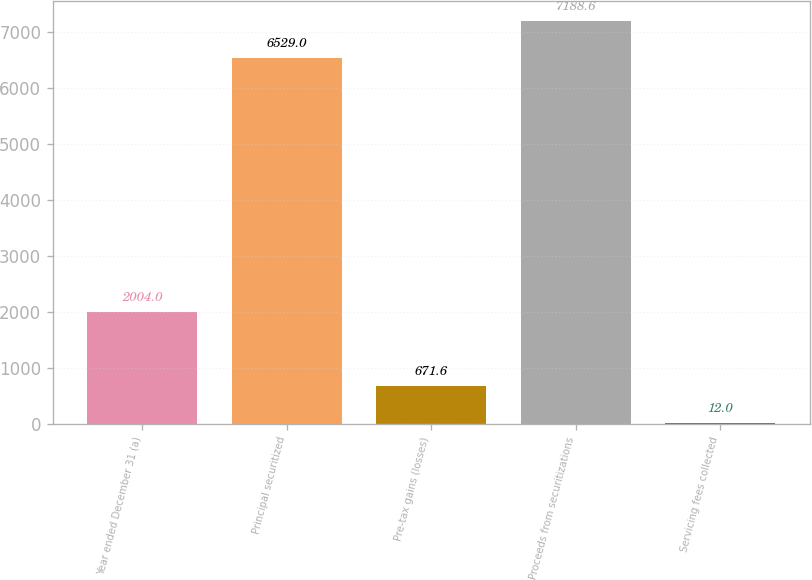Convert chart. <chart><loc_0><loc_0><loc_500><loc_500><bar_chart><fcel>Year ended December 31 (a)<fcel>Principal securitized<fcel>Pre-tax gains (losses)<fcel>Proceeds from securitizations<fcel>Servicing fees collected<nl><fcel>2004<fcel>6529<fcel>671.6<fcel>7188.6<fcel>12<nl></chart> 